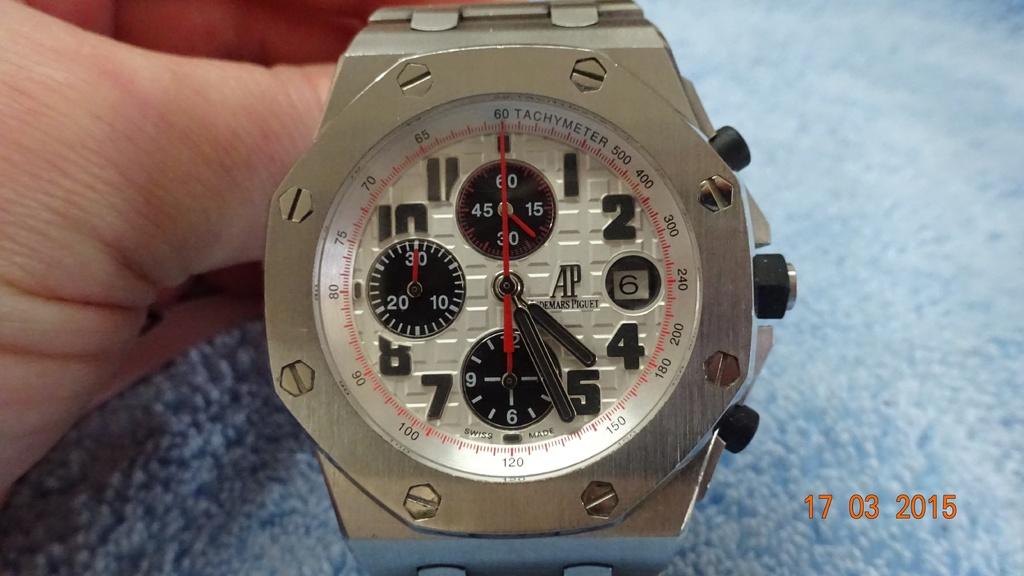What is the date on the watch?
Offer a terse response. 6. In watch time is 4.20?
Keep it short and to the point. No. 